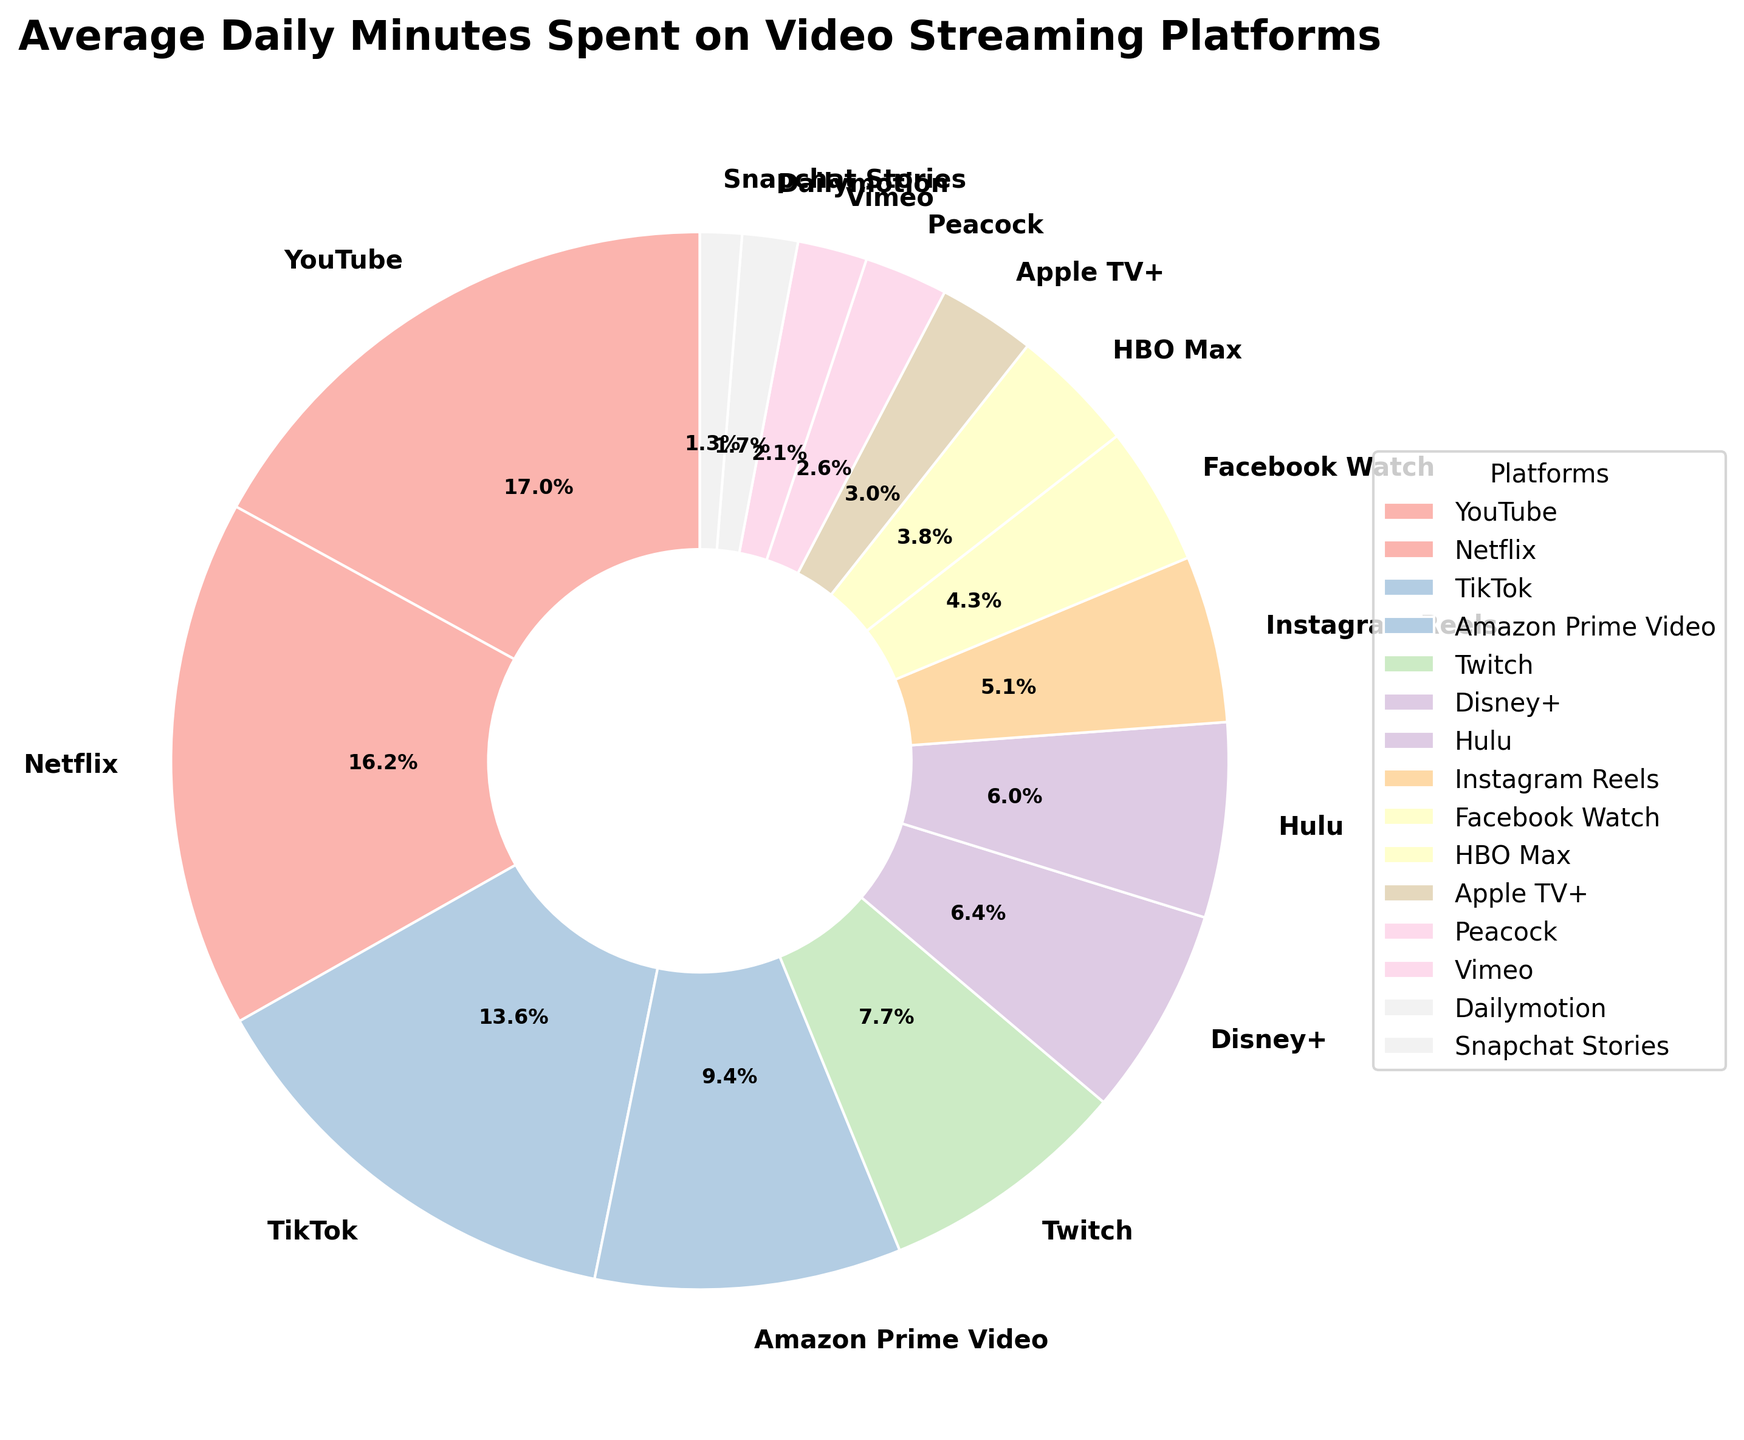Which platform has the highest average daily minutes spent? The chart shows that YouTube has the largest wedge, indicating the highest average daily minutes spent at 40 minutes.
Answer: YouTube How many platforms have an average daily time greater than 30 minutes? Observing the wedges, platforms with more than 30 minutes are YouTube (40), Netflix (38), and TikTok (32). Counting these gives 3 platforms.
Answer: 3 What is the total time spent on platforms with less than 10 minutes average daily usage? Adding the minutes for Facebook Watch (10), HBO Max (9), Apple TV+ (7), Peacock (6), Vimeo (5), Dailymotion (4), and Snapchat Stories (3) results in 44 minutes.
Answer: 44 Which platform has the least average daily minutes spent? The smallest wedge representing the least average daily minutes spent is Snapchat Stories with 3 minutes.
Answer: Snapchat Stories By how many minutes does YouTube exceed Netflix in average daily usage? Subtracting Netflix’s daily average (38 minutes) from YouTube’s (40 minutes) gives 2 minutes.
Answer: 2 What percentage of the total daily usage does Disney+ account for? The label on the Disney+ wedge shows 15 minutes out of the total. Calculating the percentage: (15 / 263) * 100 = approximately 5.7%.
Answer: 5.7% If the average daily minutes for Instagram Reels increased by 5 minutes, how would its position change relative to Hulu? Instagram Reels currently has 12 minutes, adding 5 would make it 17 minutes, which is greater than Hulu’s 14 minutes. It would then have a higher usage than Hulu.
Answer: Higher Which platform’s usage is closest to the average daily time spent on Twitch? Twitch has 18 minutes daily usage, and closest times are Disney+ with 15 minutes, and Hulu with 14 minutes. Disney+ is the closest.
Answer: Disney+ What is the combined time spent on Netflix and Amazon Prime Video daily? Adding the minutes for Netflix (38) and Amazon Prime Video (22) results in a total of 60 minutes.
Answer: 60 Which platforms have more average daily minutes than Disney+ but less than TikTok? Platforms are Amazon Prime Video (22) and Twitch (18) which fall between Disney+ (15) and TikTok (32).
Answer: Amazon Prime Video, Twitch 